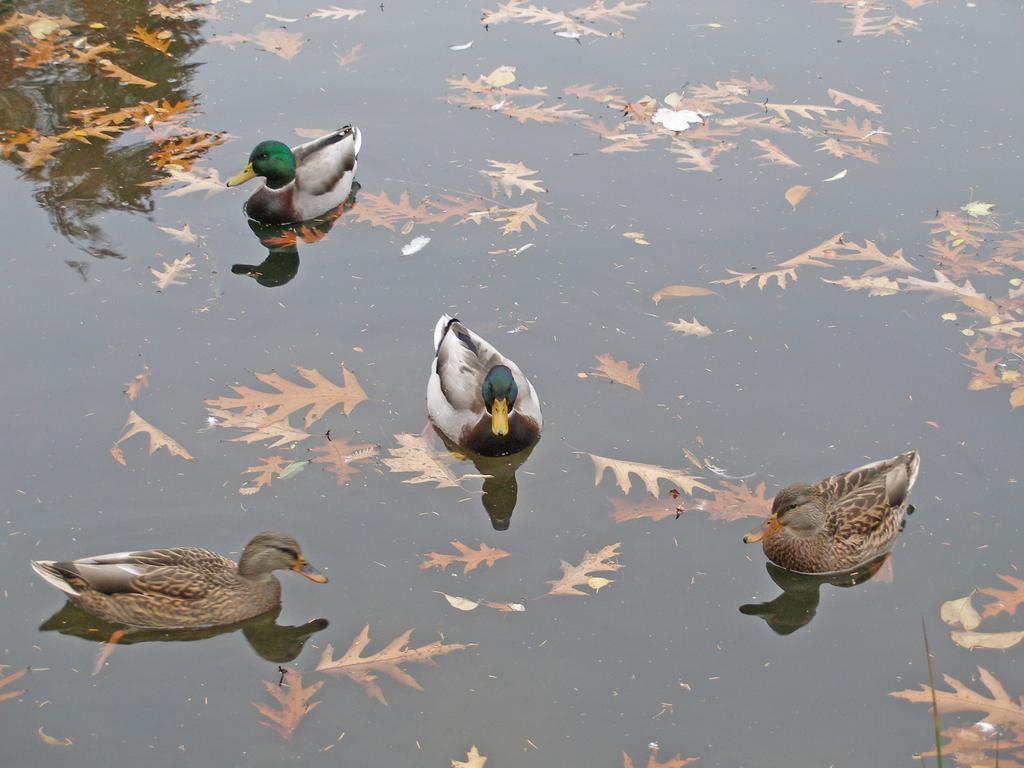Describe this image in one or two sentences. In this picture there are some ducks swimming in the water. We can observe some leaves in the water. 